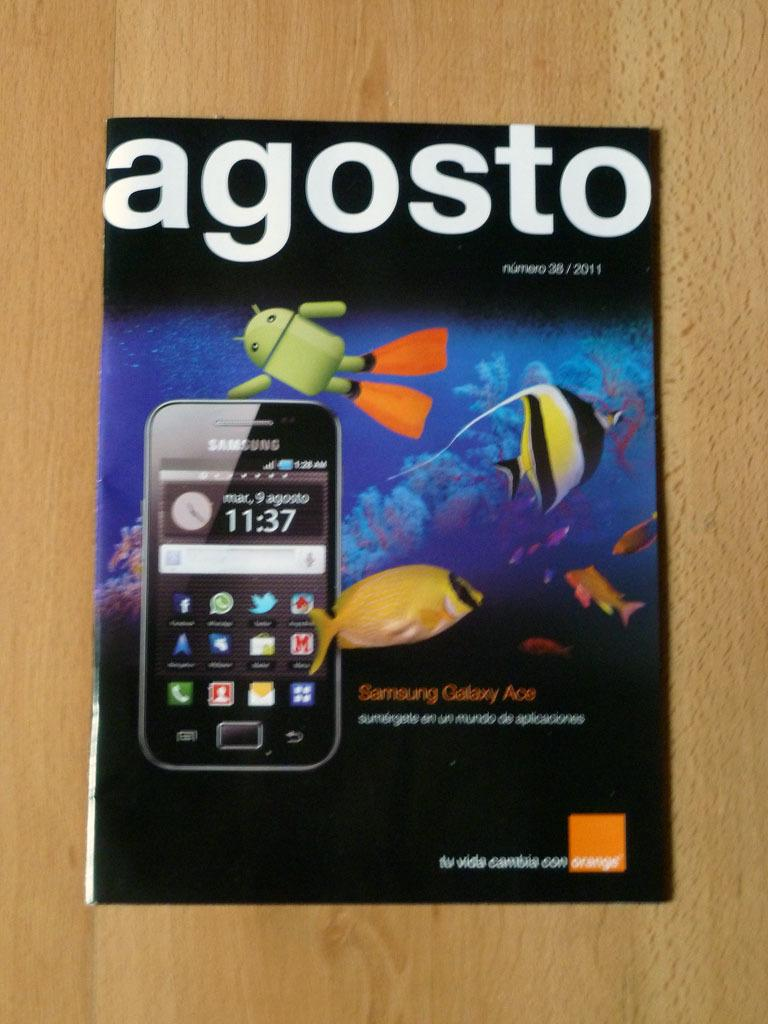<image>
Share a concise interpretation of the image provided. Book that is titled "Agosto" on top of a wooden table. 